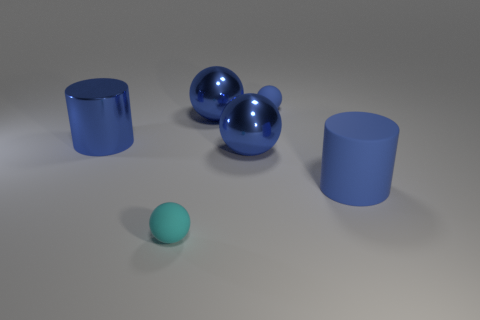Are there any tiny matte objects of the same color as the big matte object?
Offer a very short reply. Yes. Are there any big objects?
Provide a short and direct response. Yes. Is the large blue rubber thing the same shape as the cyan matte object?
Your response must be concise. No. How many large things are either blue matte cylinders or blue cylinders?
Give a very brief answer. 2. What color is the metallic cylinder?
Give a very brief answer. Blue. There is a cyan rubber thing that is to the left of the rubber object that is behind the big rubber cylinder; what is its shape?
Your answer should be compact. Sphere. Are there any cylinders that have the same material as the cyan ball?
Ensure brevity in your answer.  Yes. Does the blue rubber thing that is left of the rubber cylinder have the same size as the small cyan object?
Give a very brief answer. Yes. What number of green things are either tiny spheres or big matte things?
Your response must be concise. 0. What material is the blue cylinder to the left of the small blue rubber ball?
Your response must be concise. Metal. 